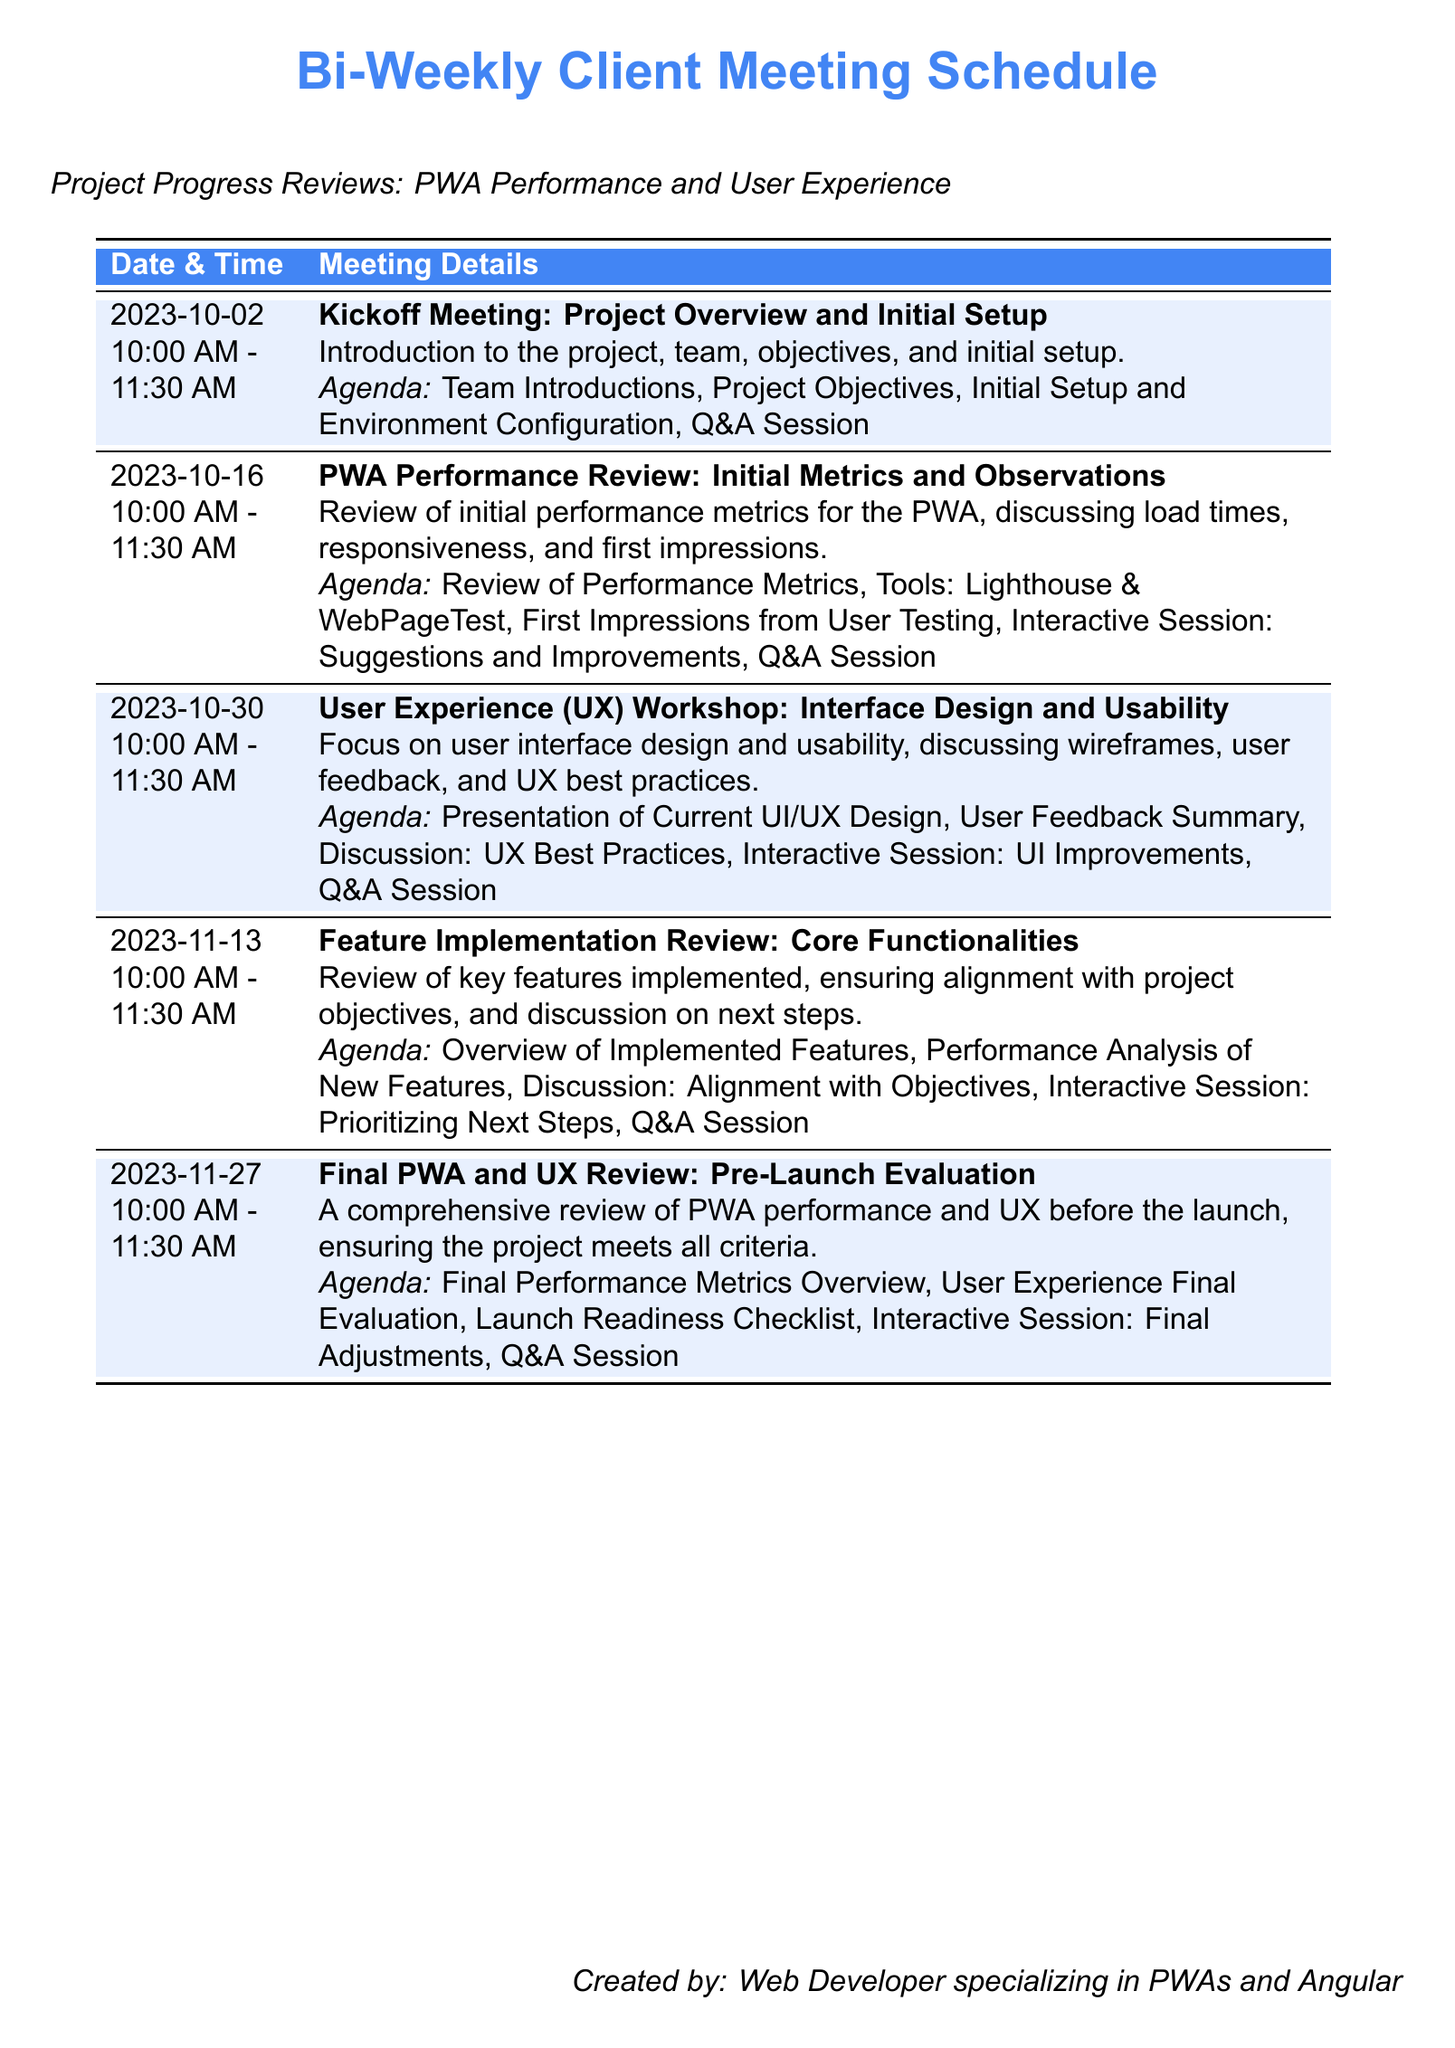What is the date of the kickoff meeting? The kickoff meeting is scheduled for October 2, 2023, as stated in the document.
Answer: October 2, 2023 What is the duration of each meeting? Each meeting is scheduled for 1 hour and 30 minutes, as indicated by the time range provided in the document.
Answer: 1 hour 30 minutes What is the focus of the meeting on October 30? The meeting on October 30 focuses on user experience and usability.
Answer: User Experience (UX) Workshop What tool is mentioned for performance review? Lighthouse is mentioned as one of the tools for the performance review discussion.
Answer: Lighthouse How many meetings are scheduled before the final review? There are four meetings scheduled before the final review on November 27, 2023.
Answer: Four What will be reviewed at the final PWA and UX review? The final performance metrics and user experience will be reviewed in the final session.
Answer: Final performance metrics and user experience What interactive session is planned for the October 16 meeting? The October 16 meeting includes an interactive session about suggestions and improvements.
Answer: Suggestions and Improvements What is the agenda item for the November 13 meeting? The agenda item includes an overview of implemented features, as listed in the meeting details.
Answer: Overview of Implemented Features 